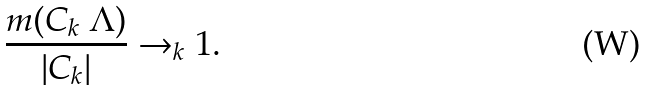<formula> <loc_0><loc_0><loc_500><loc_500>\frac { m ( C _ { k } \ \Lambda ) } { | C _ { k } | } \rightarrow _ { k } 1 .</formula> 